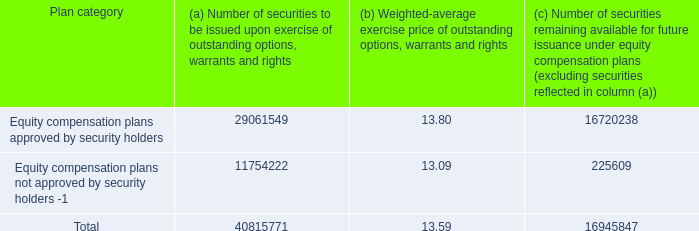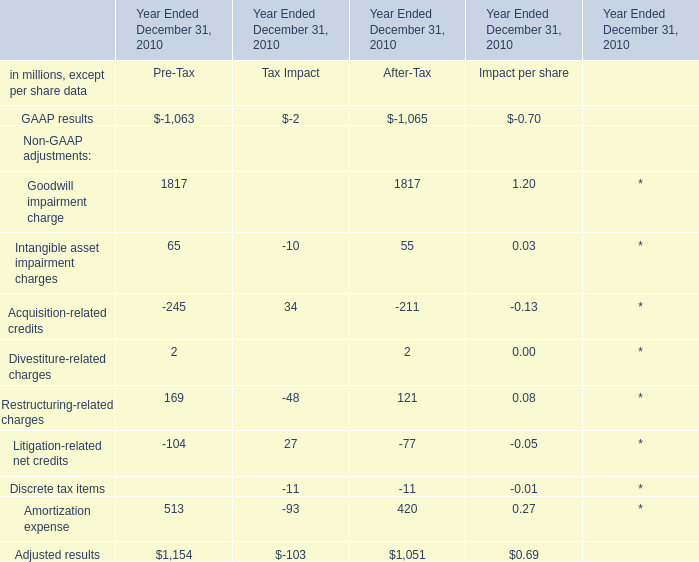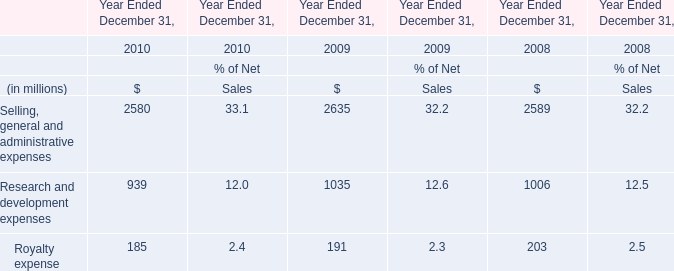What do all Goodwill impairment charge sum up without those Pre-Tax smaller than1900, in 2010? (in million) 
Answer: 1817. 